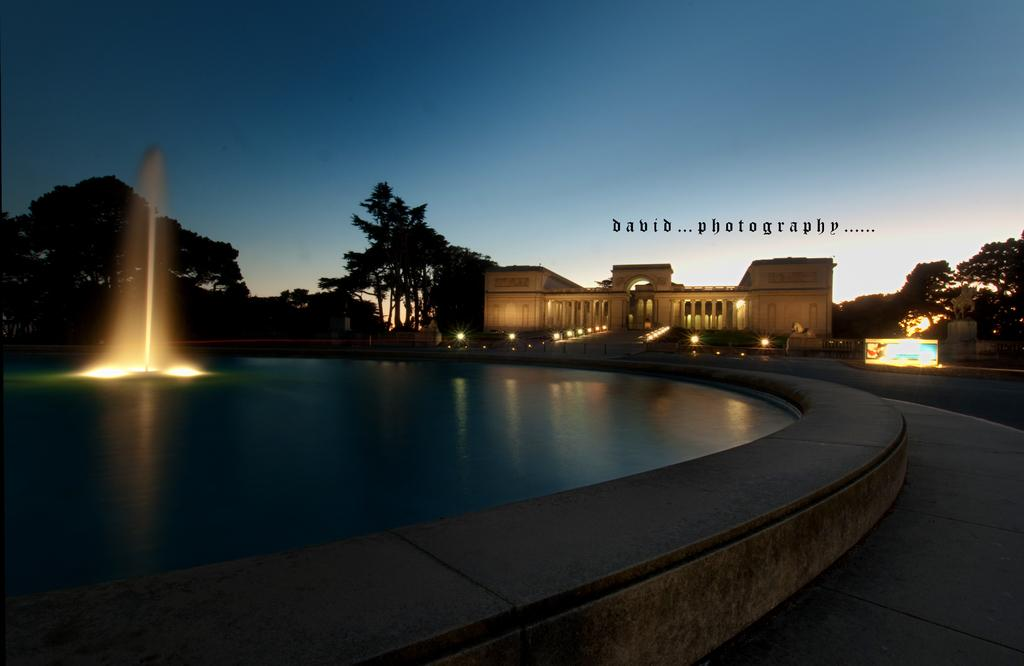What is the main feature in the image? There is a fountain with lights in the image. What can be seen in the background of the image? There are trees and a building in the background of the image. Are there any additional lighting features in the image? Yes, there are lights in front of the building. What part of the natural environment is visible in the image? The sky is visible in the background of the image. What type of yarn is being used to create the fountain in the image? There is no yarn present in the image; it features a fountain with lights. How many friends are visible in the image? There is no mention of friends in the image, as it focuses on the fountain, lights, and background elements. 